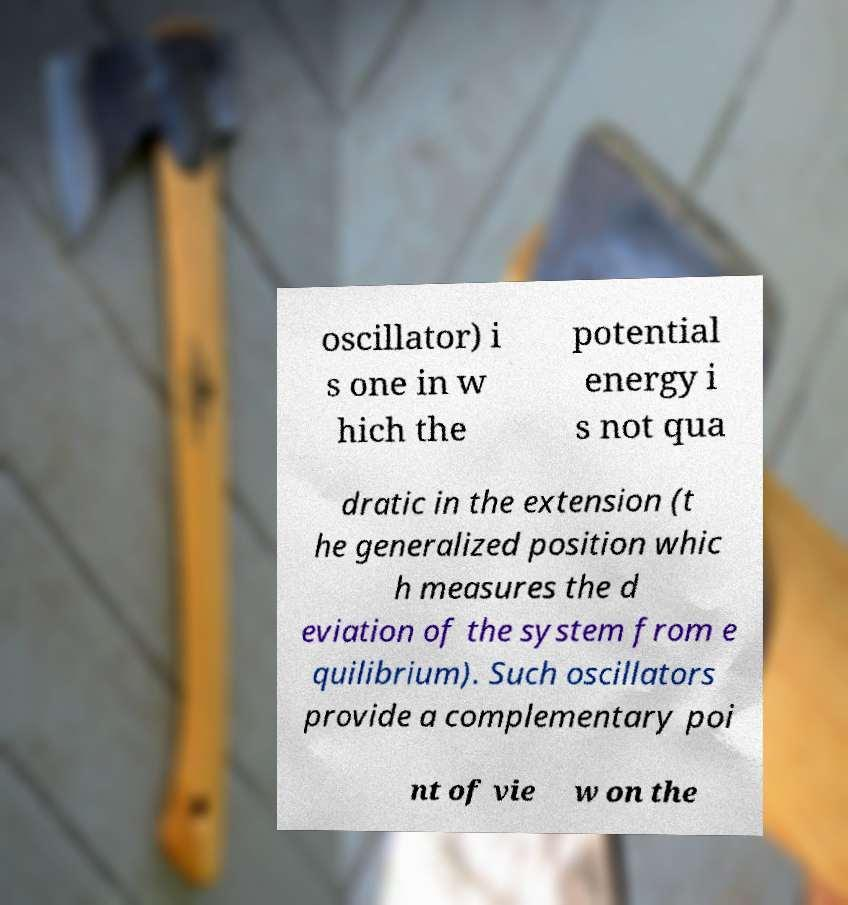What messages or text are displayed in this image? I need them in a readable, typed format. oscillator) i s one in w hich the potential energy i s not qua dratic in the extension (t he generalized position whic h measures the d eviation of the system from e quilibrium). Such oscillators provide a complementary poi nt of vie w on the 